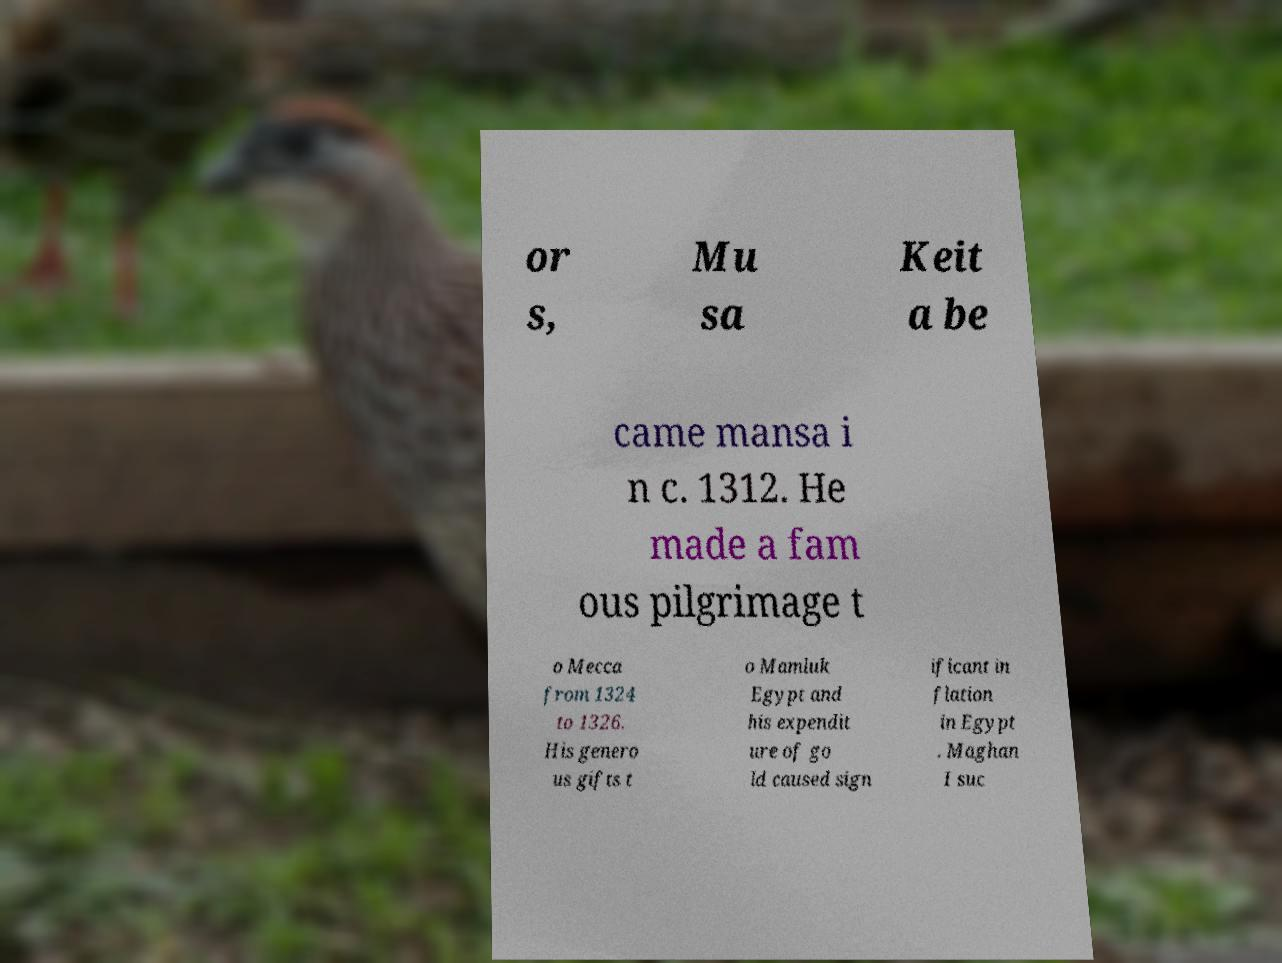I need the written content from this picture converted into text. Can you do that? or s, Mu sa Keit a be came mansa i n c. 1312. He made a fam ous pilgrimage t o Mecca from 1324 to 1326. His genero us gifts t o Mamluk Egypt and his expendit ure of go ld caused sign ificant in flation in Egypt . Maghan I suc 